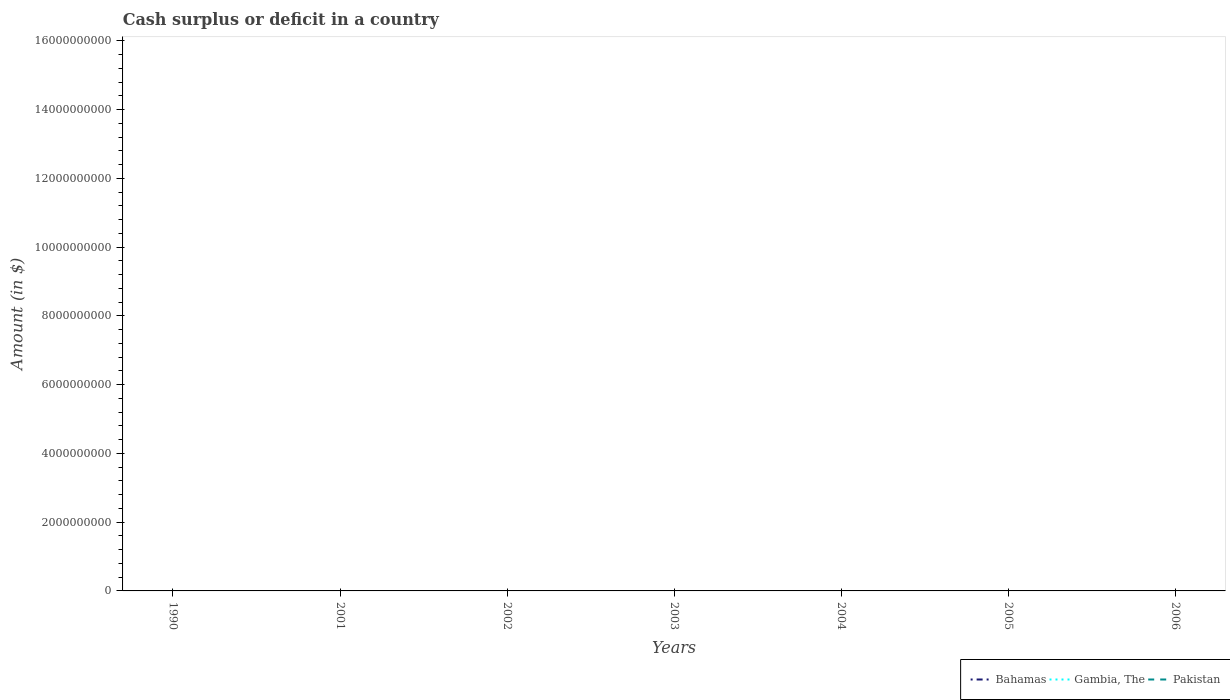Is the number of lines equal to the number of legend labels?
Your response must be concise. No. Across all years, what is the maximum amount of cash surplus or deficit in Pakistan?
Offer a terse response. 0. What is the difference between the highest and the second highest amount of cash surplus or deficit in Gambia, The?
Your answer should be compact. 3.14e+06. How many lines are there?
Offer a very short reply. 1. Does the graph contain any zero values?
Offer a very short reply. Yes. Does the graph contain grids?
Your response must be concise. No. How many legend labels are there?
Your response must be concise. 3. What is the title of the graph?
Your answer should be compact. Cash surplus or deficit in a country. Does "Cayman Islands" appear as one of the legend labels in the graph?
Offer a very short reply. No. What is the label or title of the Y-axis?
Offer a terse response. Amount (in $). What is the Amount (in $) in Gambia, The in 1990?
Your response must be concise. 3.14e+06. What is the Amount (in $) in Pakistan in 1990?
Offer a very short reply. 0. What is the Amount (in $) in Bahamas in 2001?
Give a very brief answer. 0. What is the Amount (in $) of Bahamas in 2003?
Ensure brevity in your answer.  0. What is the Amount (in $) in Gambia, The in 2004?
Give a very brief answer. 0. What is the Amount (in $) in Pakistan in 2004?
Offer a very short reply. 0. What is the Amount (in $) of Bahamas in 2005?
Make the answer very short. 0. What is the Amount (in $) in Gambia, The in 2005?
Make the answer very short. 0. What is the Amount (in $) in Pakistan in 2005?
Your answer should be very brief. 0. What is the Amount (in $) of Gambia, The in 2006?
Make the answer very short. 0. Across all years, what is the maximum Amount (in $) of Gambia, The?
Provide a succinct answer. 3.14e+06. What is the total Amount (in $) of Bahamas in the graph?
Provide a short and direct response. 0. What is the total Amount (in $) of Gambia, The in the graph?
Offer a terse response. 3.14e+06. What is the average Amount (in $) of Gambia, The per year?
Ensure brevity in your answer.  4.49e+05. What is the difference between the highest and the lowest Amount (in $) of Gambia, The?
Make the answer very short. 3.14e+06. 